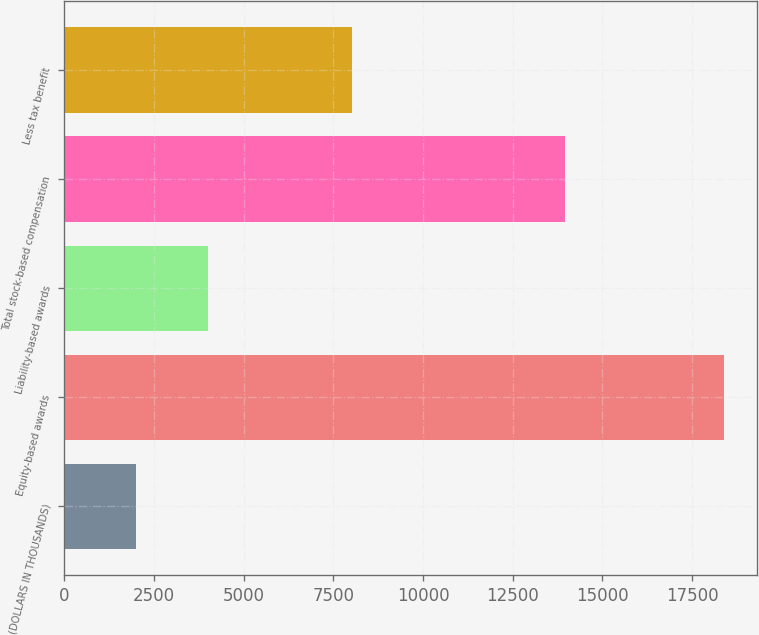Convert chart to OTSL. <chart><loc_0><loc_0><loc_500><loc_500><bar_chart><fcel>(DOLLARS IN THOUSANDS)<fcel>Equity-based awards<fcel>Liability-based awards<fcel>Total stock-based compensation<fcel>Less tax benefit<nl><fcel>2010<fcel>18382<fcel>4009.1<fcel>13973<fcel>8028<nl></chart> 